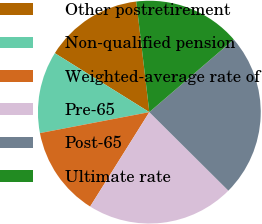<chart> <loc_0><loc_0><loc_500><loc_500><pie_chart><fcel>Other postretirement<fcel>Non-qualified pension<fcel>Weighted-average rate of<fcel>Pre-65<fcel>Post-65<fcel>Ultimate rate<nl><fcel>14.25%<fcel>11.89%<fcel>13.07%<fcel>21.46%<fcel>23.75%<fcel>15.56%<nl></chart> 